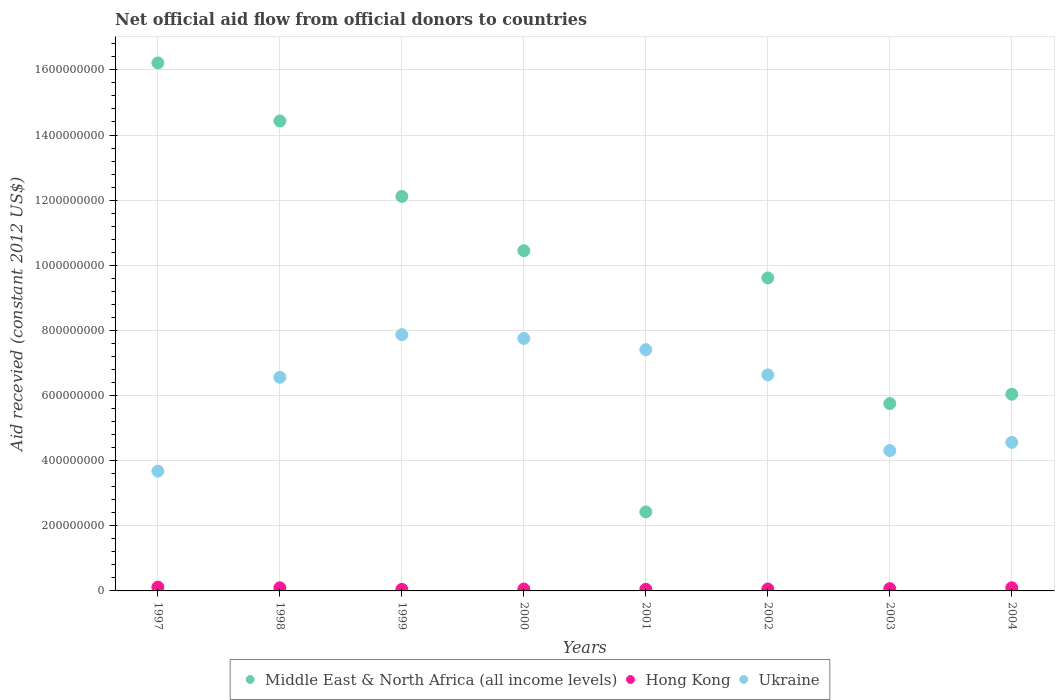How many different coloured dotlines are there?
Give a very brief answer. 3. What is the total aid received in Hong Kong in 1999?
Your answer should be compact. 4.73e+06. Across all years, what is the maximum total aid received in Ukraine?
Ensure brevity in your answer.  7.87e+08. Across all years, what is the minimum total aid received in Hong Kong?
Offer a terse response. 4.73e+06. In which year was the total aid received in Hong Kong maximum?
Offer a very short reply. 1997. What is the total total aid received in Hong Kong in the graph?
Make the answer very short. 5.97e+07. What is the difference between the total aid received in Hong Kong in 1997 and that in 2002?
Offer a very short reply. 5.88e+06. What is the difference between the total aid received in Hong Kong in 1997 and the total aid received in Ukraine in 2000?
Offer a terse response. -7.64e+08. What is the average total aid received in Ukraine per year?
Your answer should be compact. 6.10e+08. In the year 2004, what is the difference between the total aid received in Ukraine and total aid received in Middle East & North Africa (all income levels)?
Your response must be concise. -1.48e+08. What is the ratio of the total aid received in Ukraine in 1998 to that in 2000?
Provide a short and direct response. 0.85. Is the total aid received in Ukraine in 1997 less than that in 2002?
Your answer should be compact. Yes. What is the difference between the highest and the second highest total aid received in Hong Kong?
Offer a terse response. 2.15e+06. What is the difference between the highest and the lowest total aid received in Hong Kong?
Your answer should be compact. 7.07e+06. In how many years, is the total aid received in Ukraine greater than the average total aid received in Ukraine taken over all years?
Your answer should be very brief. 5. Is it the case that in every year, the sum of the total aid received in Hong Kong and total aid received in Ukraine  is greater than the total aid received in Middle East & North Africa (all income levels)?
Your response must be concise. No. Does the total aid received in Middle East & North Africa (all income levels) monotonically increase over the years?
Provide a short and direct response. No. Is the total aid received in Middle East & North Africa (all income levels) strictly less than the total aid received in Ukraine over the years?
Provide a succinct answer. No. How many dotlines are there?
Keep it short and to the point. 3. What is the difference between two consecutive major ticks on the Y-axis?
Your answer should be very brief. 2.00e+08. Does the graph contain any zero values?
Provide a short and direct response. No. Does the graph contain grids?
Your response must be concise. Yes. Where does the legend appear in the graph?
Your answer should be compact. Bottom center. What is the title of the graph?
Offer a terse response. Net official aid flow from official donors to countries. What is the label or title of the X-axis?
Your response must be concise. Years. What is the label or title of the Y-axis?
Provide a succinct answer. Aid recevied (constant 2012 US$). What is the Aid recevied (constant 2012 US$) of Middle East & North Africa (all income levels) in 1997?
Give a very brief answer. 1.62e+09. What is the Aid recevied (constant 2012 US$) of Hong Kong in 1997?
Ensure brevity in your answer.  1.18e+07. What is the Aid recevied (constant 2012 US$) in Ukraine in 1997?
Offer a terse response. 3.68e+08. What is the Aid recevied (constant 2012 US$) in Middle East & North Africa (all income levels) in 1998?
Provide a short and direct response. 1.44e+09. What is the Aid recevied (constant 2012 US$) in Hong Kong in 1998?
Offer a very short reply. 9.64e+06. What is the Aid recevied (constant 2012 US$) in Ukraine in 1998?
Your answer should be compact. 6.56e+08. What is the Aid recevied (constant 2012 US$) in Middle East & North Africa (all income levels) in 1999?
Give a very brief answer. 1.21e+09. What is the Aid recevied (constant 2012 US$) in Hong Kong in 1999?
Provide a succinct answer. 4.73e+06. What is the Aid recevied (constant 2012 US$) in Ukraine in 1999?
Provide a short and direct response. 7.87e+08. What is the Aid recevied (constant 2012 US$) of Middle East & North Africa (all income levels) in 2000?
Your response must be concise. 1.04e+09. What is the Aid recevied (constant 2012 US$) of Hong Kong in 2000?
Give a very brief answer. 5.83e+06. What is the Aid recevied (constant 2012 US$) in Ukraine in 2000?
Your answer should be compact. 7.75e+08. What is the Aid recevied (constant 2012 US$) of Middle East & North Africa (all income levels) in 2001?
Provide a succinct answer. 2.43e+08. What is the Aid recevied (constant 2012 US$) in Hong Kong in 2001?
Your answer should be compact. 5.12e+06. What is the Aid recevied (constant 2012 US$) in Ukraine in 2001?
Your response must be concise. 7.41e+08. What is the Aid recevied (constant 2012 US$) of Middle East & North Africa (all income levels) in 2002?
Offer a terse response. 9.61e+08. What is the Aid recevied (constant 2012 US$) in Hong Kong in 2002?
Keep it short and to the point. 5.92e+06. What is the Aid recevied (constant 2012 US$) in Ukraine in 2002?
Provide a succinct answer. 6.63e+08. What is the Aid recevied (constant 2012 US$) of Middle East & North Africa (all income levels) in 2003?
Offer a terse response. 5.75e+08. What is the Aid recevied (constant 2012 US$) in Hong Kong in 2003?
Give a very brief answer. 6.99e+06. What is the Aid recevied (constant 2012 US$) in Ukraine in 2003?
Ensure brevity in your answer.  4.31e+08. What is the Aid recevied (constant 2012 US$) of Middle East & North Africa (all income levels) in 2004?
Keep it short and to the point. 6.04e+08. What is the Aid recevied (constant 2012 US$) of Hong Kong in 2004?
Ensure brevity in your answer.  9.65e+06. What is the Aid recevied (constant 2012 US$) in Ukraine in 2004?
Your response must be concise. 4.56e+08. Across all years, what is the maximum Aid recevied (constant 2012 US$) of Middle East & North Africa (all income levels)?
Provide a short and direct response. 1.62e+09. Across all years, what is the maximum Aid recevied (constant 2012 US$) in Hong Kong?
Your response must be concise. 1.18e+07. Across all years, what is the maximum Aid recevied (constant 2012 US$) in Ukraine?
Keep it short and to the point. 7.87e+08. Across all years, what is the minimum Aid recevied (constant 2012 US$) in Middle East & North Africa (all income levels)?
Your response must be concise. 2.43e+08. Across all years, what is the minimum Aid recevied (constant 2012 US$) of Hong Kong?
Your answer should be very brief. 4.73e+06. Across all years, what is the minimum Aid recevied (constant 2012 US$) in Ukraine?
Ensure brevity in your answer.  3.68e+08. What is the total Aid recevied (constant 2012 US$) of Middle East & North Africa (all income levels) in the graph?
Your answer should be compact. 7.70e+09. What is the total Aid recevied (constant 2012 US$) of Hong Kong in the graph?
Offer a very short reply. 5.97e+07. What is the total Aid recevied (constant 2012 US$) in Ukraine in the graph?
Your answer should be compact. 4.88e+09. What is the difference between the Aid recevied (constant 2012 US$) of Middle East & North Africa (all income levels) in 1997 and that in 1998?
Make the answer very short. 1.78e+08. What is the difference between the Aid recevied (constant 2012 US$) of Hong Kong in 1997 and that in 1998?
Give a very brief answer. 2.16e+06. What is the difference between the Aid recevied (constant 2012 US$) of Ukraine in 1997 and that in 1998?
Keep it short and to the point. -2.88e+08. What is the difference between the Aid recevied (constant 2012 US$) in Middle East & North Africa (all income levels) in 1997 and that in 1999?
Give a very brief answer. 4.10e+08. What is the difference between the Aid recevied (constant 2012 US$) of Hong Kong in 1997 and that in 1999?
Provide a short and direct response. 7.07e+06. What is the difference between the Aid recevied (constant 2012 US$) in Ukraine in 1997 and that in 1999?
Your response must be concise. -4.19e+08. What is the difference between the Aid recevied (constant 2012 US$) of Middle East & North Africa (all income levels) in 1997 and that in 2000?
Keep it short and to the point. 5.77e+08. What is the difference between the Aid recevied (constant 2012 US$) in Hong Kong in 1997 and that in 2000?
Your answer should be compact. 5.97e+06. What is the difference between the Aid recevied (constant 2012 US$) in Ukraine in 1997 and that in 2000?
Ensure brevity in your answer.  -4.08e+08. What is the difference between the Aid recevied (constant 2012 US$) of Middle East & North Africa (all income levels) in 1997 and that in 2001?
Your response must be concise. 1.38e+09. What is the difference between the Aid recevied (constant 2012 US$) of Hong Kong in 1997 and that in 2001?
Ensure brevity in your answer.  6.68e+06. What is the difference between the Aid recevied (constant 2012 US$) of Ukraine in 1997 and that in 2001?
Provide a short and direct response. -3.73e+08. What is the difference between the Aid recevied (constant 2012 US$) in Middle East & North Africa (all income levels) in 1997 and that in 2002?
Offer a terse response. 6.60e+08. What is the difference between the Aid recevied (constant 2012 US$) of Hong Kong in 1997 and that in 2002?
Provide a short and direct response. 5.88e+06. What is the difference between the Aid recevied (constant 2012 US$) in Ukraine in 1997 and that in 2002?
Keep it short and to the point. -2.96e+08. What is the difference between the Aid recevied (constant 2012 US$) of Middle East & North Africa (all income levels) in 1997 and that in 2003?
Give a very brief answer. 1.05e+09. What is the difference between the Aid recevied (constant 2012 US$) of Hong Kong in 1997 and that in 2003?
Offer a terse response. 4.81e+06. What is the difference between the Aid recevied (constant 2012 US$) of Ukraine in 1997 and that in 2003?
Your response must be concise. -6.32e+07. What is the difference between the Aid recevied (constant 2012 US$) of Middle East & North Africa (all income levels) in 1997 and that in 2004?
Give a very brief answer. 1.02e+09. What is the difference between the Aid recevied (constant 2012 US$) of Hong Kong in 1997 and that in 2004?
Give a very brief answer. 2.15e+06. What is the difference between the Aid recevied (constant 2012 US$) of Ukraine in 1997 and that in 2004?
Offer a terse response. -8.84e+07. What is the difference between the Aid recevied (constant 2012 US$) in Middle East & North Africa (all income levels) in 1998 and that in 1999?
Your answer should be compact. 2.32e+08. What is the difference between the Aid recevied (constant 2012 US$) in Hong Kong in 1998 and that in 1999?
Make the answer very short. 4.91e+06. What is the difference between the Aid recevied (constant 2012 US$) in Ukraine in 1998 and that in 1999?
Your answer should be compact. -1.31e+08. What is the difference between the Aid recevied (constant 2012 US$) in Middle East & North Africa (all income levels) in 1998 and that in 2000?
Your answer should be very brief. 3.98e+08. What is the difference between the Aid recevied (constant 2012 US$) of Hong Kong in 1998 and that in 2000?
Your response must be concise. 3.81e+06. What is the difference between the Aid recevied (constant 2012 US$) of Ukraine in 1998 and that in 2000?
Offer a terse response. -1.19e+08. What is the difference between the Aid recevied (constant 2012 US$) of Middle East & North Africa (all income levels) in 1998 and that in 2001?
Give a very brief answer. 1.20e+09. What is the difference between the Aid recevied (constant 2012 US$) of Hong Kong in 1998 and that in 2001?
Your answer should be compact. 4.52e+06. What is the difference between the Aid recevied (constant 2012 US$) of Ukraine in 1998 and that in 2001?
Give a very brief answer. -8.49e+07. What is the difference between the Aid recevied (constant 2012 US$) in Middle East & North Africa (all income levels) in 1998 and that in 2002?
Your answer should be very brief. 4.82e+08. What is the difference between the Aid recevied (constant 2012 US$) in Hong Kong in 1998 and that in 2002?
Ensure brevity in your answer.  3.72e+06. What is the difference between the Aid recevied (constant 2012 US$) in Ukraine in 1998 and that in 2002?
Give a very brief answer. -7.41e+06. What is the difference between the Aid recevied (constant 2012 US$) in Middle East & North Africa (all income levels) in 1998 and that in 2003?
Your response must be concise. 8.68e+08. What is the difference between the Aid recevied (constant 2012 US$) of Hong Kong in 1998 and that in 2003?
Offer a very short reply. 2.65e+06. What is the difference between the Aid recevied (constant 2012 US$) of Ukraine in 1998 and that in 2003?
Your answer should be compact. 2.25e+08. What is the difference between the Aid recevied (constant 2012 US$) in Middle East & North Africa (all income levels) in 1998 and that in 2004?
Give a very brief answer. 8.39e+08. What is the difference between the Aid recevied (constant 2012 US$) of Hong Kong in 1998 and that in 2004?
Keep it short and to the point. -10000. What is the difference between the Aid recevied (constant 2012 US$) of Ukraine in 1998 and that in 2004?
Your response must be concise. 2.00e+08. What is the difference between the Aid recevied (constant 2012 US$) in Middle East & North Africa (all income levels) in 1999 and that in 2000?
Ensure brevity in your answer.  1.67e+08. What is the difference between the Aid recevied (constant 2012 US$) in Hong Kong in 1999 and that in 2000?
Offer a terse response. -1.10e+06. What is the difference between the Aid recevied (constant 2012 US$) in Ukraine in 1999 and that in 2000?
Offer a terse response. 1.14e+07. What is the difference between the Aid recevied (constant 2012 US$) in Middle East & North Africa (all income levels) in 1999 and that in 2001?
Keep it short and to the point. 9.69e+08. What is the difference between the Aid recevied (constant 2012 US$) of Hong Kong in 1999 and that in 2001?
Ensure brevity in your answer.  -3.90e+05. What is the difference between the Aid recevied (constant 2012 US$) in Ukraine in 1999 and that in 2001?
Offer a very short reply. 4.60e+07. What is the difference between the Aid recevied (constant 2012 US$) of Middle East & North Africa (all income levels) in 1999 and that in 2002?
Make the answer very short. 2.50e+08. What is the difference between the Aid recevied (constant 2012 US$) of Hong Kong in 1999 and that in 2002?
Offer a terse response. -1.19e+06. What is the difference between the Aid recevied (constant 2012 US$) in Ukraine in 1999 and that in 2002?
Provide a succinct answer. 1.23e+08. What is the difference between the Aid recevied (constant 2012 US$) in Middle East & North Africa (all income levels) in 1999 and that in 2003?
Make the answer very short. 6.36e+08. What is the difference between the Aid recevied (constant 2012 US$) of Hong Kong in 1999 and that in 2003?
Your answer should be compact. -2.26e+06. What is the difference between the Aid recevied (constant 2012 US$) in Ukraine in 1999 and that in 2003?
Offer a very short reply. 3.56e+08. What is the difference between the Aid recevied (constant 2012 US$) of Middle East & North Africa (all income levels) in 1999 and that in 2004?
Ensure brevity in your answer.  6.07e+08. What is the difference between the Aid recevied (constant 2012 US$) in Hong Kong in 1999 and that in 2004?
Offer a terse response. -4.92e+06. What is the difference between the Aid recevied (constant 2012 US$) of Ukraine in 1999 and that in 2004?
Offer a very short reply. 3.31e+08. What is the difference between the Aid recevied (constant 2012 US$) of Middle East & North Africa (all income levels) in 2000 and that in 2001?
Offer a terse response. 8.02e+08. What is the difference between the Aid recevied (constant 2012 US$) of Hong Kong in 2000 and that in 2001?
Provide a short and direct response. 7.10e+05. What is the difference between the Aid recevied (constant 2012 US$) of Ukraine in 2000 and that in 2001?
Your response must be concise. 3.46e+07. What is the difference between the Aid recevied (constant 2012 US$) of Middle East & North Africa (all income levels) in 2000 and that in 2002?
Your answer should be compact. 8.36e+07. What is the difference between the Aid recevied (constant 2012 US$) in Hong Kong in 2000 and that in 2002?
Give a very brief answer. -9.00e+04. What is the difference between the Aid recevied (constant 2012 US$) in Ukraine in 2000 and that in 2002?
Your response must be concise. 1.12e+08. What is the difference between the Aid recevied (constant 2012 US$) in Middle East & North Africa (all income levels) in 2000 and that in 2003?
Keep it short and to the point. 4.69e+08. What is the difference between the Aid recevied (constant 2012 US$) of Hong Kong in 2000 and that in 2003?
Provide a succinct answer. -1.16e+06. What is the difference between the Aid recevied (constant 2012 US$) of Ukraine in 2000 and that in 2003?
Give a very brief answer. 3.44e+08. What is the difference between the Aid recevied (constant 2012 US$) of Middle East & North Africa (all income levels) in 2000 and that in 2004?
Provide a succinct answer. 4.41e+08. What is the difference between the Aid recevied (constant 2012 US$) in Hong Kong in 2000 and that in 2004?
Provide a succinct answer. -3.82e+06. What is the difference between the Aid recevied (constant 2012 US$) of Ukraine in 2000 and that in 2004?
Offer a very short reply. 3.19e+08. What is the difference between the Aid recevied (constant 2012 US$) of Middle East & North Africa (all income levels) in 2001 and that in 2002?
Ensure brevity in your answer.  -7.19e+08. What is the difference between the Aid recevied (constant 2012 US$) of Hong Kong in 2001 and that in 2002?
Keep it short and to the point. -8.00e+05. What is the difference between the Aid recevied (constant 2012 US$) of Ukraine in 2001 and that in 2002?
Ensure brevity in your answer.  7.75e+07. What is the difference between the Aid recevied (constant 2012 US$) in Middle East & North Africa (all income levels) in 2001 and that in 2003?
Your answer should be very brief. -3.33e+08. What is the difference between the Aid recevied (constant 2012 US$) in Hong Kong in 2001 and that in 2003?
Your answer should be very brief. -1.87e+06. What is the difference between the Aid recevied (constant 2012 US$) of Ukraine in 2001 and that in 2003?
Keep it short and to the point. 3.10e+08. What is the difference between the Aid recevied (constant 2012 US$) of Middle East & North Africa (all income levels) in 2001 and that in 2004?
Ensure brevity in your answer.  -3.61e+08. What is the difference between the Aid recevied (constant 2012 US$) in Hong Kong in 2001 and that in 2004?
Keep it short and to the point. -4.53e+06. What is the difference between the Aid recevied (constant 2012 US$) of Ukraine in 2001 and that in 2004?
Make the answer very short. 2.85e+08. What is the difference between the Aid recevied (constant 2012 US$) of Middle East & North Africa (all income levels) in 2002 and that in 2003?
Your response must be concise. 3.86e+08. What is the difference between the Aid recevied (constant 2012 US$) in Hong Kong in 2002 and that in 2003?
Provide a succinct answer. -1.07e+06. What is the difference between the Aid recevied (constant 2012 US$) in Ukraine in 2002 and that in 2003?
Offer a very short reply. 2.32e+08. What is the difference between the Aid recevied (constant 2012 US$) of Middle East & North Africa (all income levels) in 2002 and that in 2004?
Your answer should be compact. 3.57e+08. What is the difference between the Aid recevied (constant 2012 US$) in Hong Kong in 2002 and that in 2004?
Keep it short and to the point. -3.73e+06. What is the difference between the Aid recevied (constant 2012 US$) of Ukraine in 2002 and that in 2004?
Your answer should be compact. 2.07e+08. What is the difference between the Aid recevied (constant 2012 US$) of Middle East & North Africa (all income levels) in 2003 and that in 2004?
Your answer should be compact. -2.86e+07. What is the difference between the Aid recevied (constant 2012 US$) of Hong Kong in 2003 and that in 2004?
Your answer should be very brief. -2.66e+06. What is the difference between the Aid recevied (constant 2012 US$) in Ukraine in 2003 and that in 2004?
Offer a very short reply. -2.51e+07. What is the difference between the Aid recevied (constant 2012 US$) in Middle East & North Africa (all income levels) in 1997 and the Aid recevied (constant 2012 US$) in Hong Kong in 1998?
Your response must be concise. 1.61e+09. What is the difference between the Aid recevied (constant 2012 US$) of Middle East & North Africa (all income levels) in 1997 and the Aid recevied (constant 2012 US$) of Ukraine in 1998?
Your answer should be compact. 9.65e+08. What is the difference between the Aid recevied (constant 2012 US$) in Hong Kong in 1997 and the Aid recevied (constant 2012 US$) in Ukraine in 1998?
Provide a short and direct response. -6.44e+08. What is the difference between the Aid recevied (constant 2012 US$) in Middle East & North Africa (all income levels) in 1997 and the Aid recevied (constant 2012 US$) in Hong Kong in 1999?
Keep it short and to the point. 1.62e+09. What is the difference between the Aid recevied (constant 2012 US$) of Middle East & North Africa (all income levels) in 1997 and the Aid recevied (constant 2012 US$) of Ukraine in 1999?
Provide a succinct answer. 8.35e+08. What is the difference between the Aid recevied (constant 2012 US$) in Hong Kong in 1997 and the Aid recevied (constant 2012 US$) in Ukraine in 1999?
Give a very brief answer. -7.75e+08. What is the difference between the Aid recevied (constant 2012 US$) of Middle East & North Africa (all income levels) in 1997 and the Aid recevied (constant 2012 US$) of Hong Kong in 2000?
Provide a short and direct response. 1.62e+09. What is the difference between the Aid recevied (constant 2012 US$) of Middle East & North Africa (all income levels) in 1997 and the Aid recevied (constant 2012 US$) of Ukraine in 2000?
Your response must be concise. 8.46e+08. What is the difference between the Aid recevied (constant 2012 US$) in Hong Kong in 1997 and the Aid recevied (constant 2012 US$) in Ukraine in 2000?
Your answer should be compact. -7.64e+08. What is the difference between the Aid recevied (constant 2012 US$) of Middle East & North Africa (all income levels) in 1997 and the Aid recevied (constant 2012 US$) of Hong Kong in 2001?
Give a very brief answer. 1.62e+09. What is the difference between the Aid recevied (constant 2012 US$) in Middle East & North Africa (all income levels) in 1997 and the Aid recevied (constant 2012 US$) in Ukraine in 2001?
Provide a short and direct response. 8.81e+08. What is the difference between the Aid recevied (constant 2012 US$) of Hong Kong in 1997 and the Aid recevied (constant 2012 US$) of Ukraine in 2001?
Your answer should be compact. -7.29e+08. What is the difference between the Aid recevied (constant 2012 US$) of Middle East & North Africa (all income levels) in 1997 and the Aid recevied (constant 2012 US$) of Hong Kong in 2002?
Provide a short and direct response. 1.62e+09. What is the difference between the Aid recevied (constant 2012 US$) in Middle East & North Africa (all income levels) in 1997 and the Aid recevied (constant 2012 US$) in Ukraine in 2002?
Your answer should be compact. 9.58e+08. What is the difference between the Aid recevied (constant 2012 US$) in Hong Kong in 1997 and the Aid recevied (constant 2012 US$) in Ukraine in 2002?
Make the answer very short. -6.52e+08. What is the difference between the Aid recevied (constant 2012 US$) of Middle East & North Africa (all income levels) in 1997 and the Aid recevied (constant 2012 US$) of Hong Kong in 2003?
Ensure brevity in your answer.  1.61e+09. What is the difference between the Aid recevied (constant 2012 US$) of Middle East & North Africa (all income levels) in 1997 and the Aid recevied (constant 2012 US$) of Ukraine in 2003?
Your answer should be very brief. 1.19e+09. What is the difference between the Aid recevied (constant 2012 US$) in Hong Kong in 1997 and the Aid recevied (constant 2012 US$) in Ukraine in 2003?
Offer a terse response. -4.19e+08. What is the difference between the Aid recevied (constant 2012 US$) of Middle East & North Africa (all income levels) in 1997 and the Aid recevied (constant 2012 US$) of Hong Kong in 2004?
Offer a very short reply. 1.61e+09. What is the difference between the Aid recevied (constant 2012 US$) in Middle East & North Africa (all income levels) in 1997 and the Aid recevied (constant 2012 US$) in Ukraine in 2004?
Your response must be concise. 1.17e+09. What is the difference between the Aid recevied (constant 2012 US$) of Hong Kong in 1997 and the Aid recevied (constant 2012 US$) of Ukraine in 2004?
Ensure brevity in your answer.  -4.44e+08. What is the difference between the Aid recevied (constant 2012 US$) in Middle East & North Africa (all income levels) in 1998 and the Aid recevied (constant 2012 US$) in Hong Kong in 1999?
Keep it short and to the point. 1.44e+09. What is the difference between the Aid recevied (constant 2012 US$) in Middle East & North Africa (all income levels) in 1998 and the Aid recevied (constant 2012 US$) in Ukraine in 1999?
Give a very brief answer. 6.56e+08. What is the difference between the Aid recevied (constant 2012 US$) in Hong Kong in 1998 and the Aid recevied (constant 2012 US$) in Ukraine in 1999?
Give a very brief answer. -7.77e+08. What is the difference between the Aid recevied (constant 2012 US$) of Middle East & North Africa (all income levels) in 1998 and the Aid recevied (constant 2012 US$) of Hong Kong in 2000?
Offer a very short reply. 1.44e+09. What is the difference between the Aid recevied (constant 2012 US$) in Middle East & North Africa (all income levels) in 1998 and the Aid recevied (constant 2012 US$) in Ukraine in 2000?
Provide a short and direct response. 6.68e+08. What is the difference between the Aid recevied (constant 2012 US$) in Hong Kong in 1998 and the Aid recevied (constant 2012 US$) in Ukraine in 2000?
Keep it short and to the point. -7.66e+08. What is the difference between the Aid recevied (constant 2012 US$) in Middle East & North Africa (all income levels) in 1998 and the Aid recevied (constant 2012 US$) in Hong Kong in 2001?
Give a very brief answer. 1.44e+09. What is the difference between the Aid recevied (constant 2012 US$) of Middle East & North Africa (all income levels) in 1998 and the Aid recevied (constant 2012 US$) of Ukraine in 2001?
Keep it short and to the point. 7.02e+08. What is the difference between the Aid recevied (constant 2012 US$) in Hong Kong in 1998 and the Aid recevied (constant 2012 US$) in Ukraine in 2001?
Offer a terse response. -7.31e+08. What is the difference between the Aid recevied (constant 2012 US$) in Middle East & North Africa (all income levels) in 1998 and the Aid recevied (constant 2012 US$) in Hong Kong in 2002?
Provide a succinct answer. 1.44e+09. What is the difference between the Aid recevied (constant 2012 US$) in Middle East & North Africa (all income levels) in 1998 and the Aid recevied (constant 2012 US$) in Ukraine in 2002?
Provide a succinct answer. 7.80e+08. What is the difference between the Aid recevied (constant 2012 US$) in Hong Kong in 1998 and the Aid recevied (constant 2012 US$) in Ukraine in 2002?
Give a very brief answer. -6.54e+08. What is the difference between the Aid recevied (constant 2012 US$) of Middle East & North Africa (all income levels) in 1998 and the Aid recevied (constant 2012 US$) of Hong Kong in 2003?
Your answer should be compact. 1.44e+09. What is the difference between the Aid recevied (constant 2012 US$) of Middle East & North Africa (all income levels) in 1998 and the Aid recevied (constant 2012 US$) of Ukraine in 2003?
Keep it short and to the point. 1.01e+09. What is the difference between the Aid recevied (constant 2012 US$) of Hong Kong in 1998 and the Aid recevied (constant 2012 US$) of Ukraine in 2003?
Offer a very short reply. -4.21e+08. What is the difference between the Aid recevied (constant 2012 US$) of Middle East & North Africa (all income levels) in 1998 and the Aid recevied (constant 2012 US$) of Hong Kong in 2004?
Give a very brief answer. 1.43e+09. What is the difference between the Aid recevied (constant 2012 US$) of Middle East & North Africa (all income levels) in 1998 and the Aid recevied (constant 2012 US$) of Ukraine in 2004?
Your answer should be very brief. 9.87e+08. What is the difference between the Aid recevied (constant 2012 US$) in Hong Kong in 1998 and the Aid recevied (constant 2012 US$) in Ukraine in 2004?
Give a very brief answer. -4.47e+08. What is the difference between the Aid recevied (constant 2012 US$) in Middle East & North Africa (all income levels) in 1999 and the Aid recevied (constant 2012 US$) in Hong Kong in 2000?
Give a very brief answer. 1.21e+09. What is the difference between the Aid recevied (constant 2012 US$) in Middle East & North Africa (all income levels) in 1999 and the Aid recevied (constant 2012 US$) in Ukraine in 2000?
Your answer should be very brief. 4.36e+08. What is the difference between the Aid recevied (constant 2012 US$) of Hong Kong in 1999 and the Aid recevied (constant 2012 US$) of Ukraine in 2000?
Offer a very short reply. -7.71e+08. What is the difference between the Aid recevied (constant 2012 US$) in Middle East & North Africa (all income levels) in 1999 and the Aid recevied (constant 2012 US$) in Hong Kong in 2001?
Provide a short and direct response. 1.21e+09. What is the difference between the Aid recevied (constant 2012 US$) of Middle East & North Africa (all income levels) in 1999 and the Aid recevied (constant 2012 US$) of Ukraine in 2001?
Provide a succinct answer. 4.70e+08. What is the difference between the Aid recevied (constant 2012 US$) of Hong Kong in 1999 and the Aid recevied (constant 2012 US$) of Ukraine in 2001?
Provide a short and direct response. -7.36e+08. What is the difference between the Aid recevied (constant 2012 US$) of Middle East & North Africa (all income levels) in 1999 and the Aid recevied (constant 2012 US$) of Hong Kong in 2002?
Your response must be concise. 1.21e+09. What is the difference between the Aid recevied (constant 2012 US$) of Middle East & North Africa (all income levels) in 1999 and the Aid recevied (constant 2012 US$) of Ukraine in 2002?
Your response must be concise. 5.48e+08. What is the difference between the Aid recevied (constant 2012 US$) of Hong Kong in 1999 and the Aid recevied (constant 2012 US$) of Ukraine in 2002?
Provide a short and direct response. -6.59e+08. What is the difference between the Aid recevied (constant 2012 US$) of Middle East & North Africa (all income levels) in 1999 and the Aid recevied (constant 2012 US$) of Hong Kong in 2003?
Offer a terse response. 1.20e+09. What is the difference between the Aid recevied (constant 2012 US$) of Middle East & North Africa (all income levels) in 1999 and the Aid recevied (constant 2012 US$) of Ukraine in 2003?
Offer a terse response. 7.80e+08. What is the difference between the Aid recevied (constant 2012 US$) of Hong Kong in 1999 and the Aid recevied (constant 2012 US$) of Ukraine in 2003?
Provide a short and direct response. -4.26e+08. What is the difference between the Aid recevied (constant 2012 US$) in Middle East & North Africa (all income levels) in 1999 and the Aid recevied (constant 2012 US$) in Hong Kong in 2004?
Give a very brief answer. 1.20e+09. What is the difference between the Aid recevied (constant 2012 US$) of Middle East & North Africa (all income levels) in 1999 and the Aid recevied (constant 2012 US$) of Ukraine in 2004?
Offer a very short reply. 7.55e+08. What is the difference between the Aid recevied (constant 2012 US$) of Hong Kong in 1999 and the Aid recevied (constant 2012 US$) of Ukraine in 2004?
Offer a very short reply. -4.51e+08. What is the difference between the Aid recevied (constant 2012 US$) of Middle East & North Africa (all income levels) in 2000 and the Aid recevied (constant 2012 US$) of Hong Kong in 2001?
Offer a very short reply. 1.04e+09. What is the difference between the Aid recevied (constant 2012 US$) of Middle East & North Africa (all income levels) in 2000 and the Aid recevied (constant 2012 US$) of Ukraine in 2001?
Provide a short and direct response. 3.04e+08. What is the difference between the Aid recevied (constant 2012 US$) of Hong Kong in 2000 and the Aid recevied (constant 2012 US$) of Ukraine in 2001?
Keep it short and to the point. -7.35e+08. What is the difference between the Aid recevied (constant 2012 US$) in Middle East & North Africa (all income levels) in 2000 and the Aid recevied (constant 2012 US$) in Hong Kong in 2002?
Offer a very short reply. 1.04e+09. What is the difference between the Aid recevied (constant 2012 US$) of Middle East & North Africa (all income levels) in 2000 and the Aid recevied (constant 2012 US$) of Ukraine in 2002?
Keep it short and to the point. 3.81e+08. What is the difference between the Aid recevied (constant 2012 US$) of Hong Kong in 2000 and the Aid recevied (constant 2012 US$) of Ukraine in 2002?
Provide a succinct answer. -6.58e+08. What is the difference between the Aid recevied (constant 2012 US$) of Middle East & North Africa (all income levels) in 2000 and the Aid recevied (constant 2012 US$) of Hong Kong in 2003?
Provide a succinct answer. 1.04e+09. What is the difference between the Aid recevied (constant 2012 US$) in Middle East & North Africa (all income levels) in 2000 and the Aid recevied (constant 2012 US$) in Ukraine in 2003?
Ensure brevity in your answer.  6.14e+08. What is the difference between the Aid recevied (constant 2012 US$) in Hong Kong in 2000 and the Aid recevied (constant 2012 US$) in Ukraine in 2003?
Offer a terse response. -4.25e+08. What is the difference between the Aid recevied (constant 2012 US$) in Middle East & North Africa (all income levels) in 2000 and the Aid recevied (constant 2012 US$) in Hong Kong in 2004?
Offer a very short reply. 1.04e+09. What is the difference between the Aid recevied (constant 2012 US$) of Middle East & North Africa (all income levels) in 2000 and the Aid recevied (constant 2012 US$) of Ukraine in 2004?
Offer a terse response. 5.89e+08. What is the difference between the Aid recevied (constant 2012 US$) in Hong Kong in 2000 and the Aid recevied (constant 2012 US$) in Ukraine in 2004?
Offer a terse response. -4.50e+08. What is the difference between the Aid recevied (constant 2012 US$) in Middle East & North Africa (all income levels) in 2001 and the Aid recevied (constant 2012 US$) in Hong Kong in 2002?
Your answer should be compact. 2.37e+08. What is the difference between the Aid recevied (constant 2012 US$) in Middle East & North Africa (all income levels) in 2001 and the Aid recevied (constant 2012 US$) in Ukraine in 2002?
Your response must be concise. -4.21e+08. What is the difference between the Aid recevied (constant 2012 US$) in Hong Kong in 2001 and the Aid recevied (constant 2012 US$) in Ukraine in 2002?
Your answer should be very brief. -6.58e+08. What is the difference between the Aid recevied (constant 2012 US$) of Middle East & North Africa (all income levels) in 2001 and the Aid recevied (constant 2012 US$) of Hong Kong in 2003?
Keep it short and to the point. 2.36e+08. What is the difference between the Aid recevied (constant 2012 US$) in Middle East & North Africa (all income levels) in 2001 and the Aid recevied (constant 2012 US$) in Ukraine in 2003?
Provide a succinct answer. -1.89e+08. What is the difference between the Aid recevied (constant 2012 US$) of Hong Kong in 2001 and the Aid recevied (constant 2012 US$) of Ukraine in 2003?
Your response must be concise. -4.26e+08. What is the difference between the Aid recevied (constant 2012 US$) in Middle East & North Africa (all income levels) in 2001 and the Aid recevied (constant 2012 US$) in Hong Kong in 2004?
Offer a very short reply. 2.33e+08. What is the difference between the Aid recevied (constant 2012 US$) of Middle East & North Africa (all income levels) in 2001 and the Aid recevied (constant 2012 US$) of Ukraine in 2004?
Make the answer very short. -2.14e+08. What is the difference between the Aid recevied (constant 2012 US$) of Hong Kong in 2001 and the Aid recevied (constant 2012 US$) of Ukraine in 2004?
Keep it short and to the point. -4.51e+08. What is the difference between the Aid recevied (constant 2012 US$) in Middle East & North Africa (all income levels) in 2002 and the Aid recevied (constant 2012 US$) in Hong Kong in 2003?
Keep it short and to the point. 9.54e+08. What is the difference between the Aid recevied (constant 2012 US$) in Middle East & North Africa (all income levels) in 2002 and the Aid recevied (constant 2012 US$) in Ukraine in 2003?
Provide a short and direct response. 5.30e+08. What is the difference between the Aid recevied (constant 2012 US$) in Hong Kong in 2002 and the Aid recevied (constant 2012 US$) in Ukraine in 2003?
Give a very brief answer. -4.25e+08. What is the difference between the Aid recevied (constant 2012 US$) in Middle East & North Africa (all income levels) in 2002 and the Aid recevied (constant 2012 US$) in Hong Kong in 2004?
Your response must be concise. 9.52e+08. What is the difference between the Aid recevied (constant 2012 US$) in Middle East & North Africa (all income levels) in 2002 and the Aid recevied (constant 2012 US$) in Ukraine in 2004?
Your response must be concise. 5.05e+08. What is the difference between the Aid recevied (constant 2012 US$) in Hong Kong in 2002 and the Aid recevied (constant 2012 US$) in Ukraine in 2004?
Give a very brief answer. -4.50e+08. What is the difference between the Aid recevied (constant 2012 US$) in Middle East & North Africa (all income levels) in 2003 and the Aid recevied (constant 2012 US$) in Hong Kong in 2004?
Your answer should be compact. 5.66e+08. What is the difference between the Aid recevied (constant 2012 US$) in Middle East & North Africa (all income levels) in 2003 and the Aid recevied (constant 2012 US$) in Ukraine in 2004?
Your answer should be compact. 1.19e+08. What is the difference between the Aid recevied (constant 2012 US$) in Hong Kong in 2003 and the Aid recevied (constant 2012 US$) in Ukraine in 2004?
Keep it short and to the point. -4.49e+08. What is the average Aid recevied (constant 2012 US$) in Middle East & North Africa (all income levels) per year?
Your answer should be compact. 9.63e+08. What is the average Aid recevied (constant 2012 US$) in Hong Kong per year?
Your answer should be very brief. 7.46e+06. What is the average Aid recevied (constant 2012 US$) of Ukraine per year?
Your answer should be very brief. 6.10e+08. In the year 1997, what is the difference between the Aid recevied (constant 2012 US$) in Middle East & North Africa (all income levels) and Aid recevied (constant 2012 US$) in Hong Kong?
Offer a terse response. 1.61e+09. In the year 1997, what is the difference between the Aid recevied (constant 2012 US$) in Middle East & North Africa (all income levels) and Aid recevied (constant 2012 US$) in Ukraine?
Offer a very short reply. 1.25e+09. In the year 1997, what is the difference between the Aid recevied (constant 2012 US$) of Hong Kong and Aid recevied (constant 2012 US$) of Ukraine?
Ensure brevity in your answer.  -3.56e+08. In the year 1998, what is the difference between the Aid recevied (constant 2012 US$) of Middle East & North Africa (all income levels) and Aid recevied (constant 2012 US$) of Hong Kong?
Provide a short and direct response. 1.43e+09. In the year 1998, what is the difference between the Aid recevied (constant 2012 US$) of Middle East & North Africa (all income levels) and Aid recevied (constant 2012 US$) of Ukraine?
Provide a short and direct response. 7.87e+08. In the year 1998, what is the difference between the Aid recevied (constant 2012 US$) in Hong Kong and Aid recevied (constant 2012 US$) in Ukraine?
Your answer should be compact. -6.46e+08. In the year 1999, what is the difference between the Aid recevied (constant 2012 US$) in Middle East & North Africa (all income levels) and Aid recevied (constant 2012 US$) in Hong Kong?
Provide a short and direct response. 1.21e+09. In the year 1999, what is the difference between the Aid recevied (constant 2012 US$) in Middle East & North Africa (all income levels) and Aid recevied (constant 2012 US$) in Ukraine?
Your response must be concise. 4.24e+08. In the year 1999, what is the difference between the Aid recevied (constant 2012 US$) of Hong Kong and Aid recevied (constant 2012 US$) of Ukraine?
Your answer should be compact. -7.82e+08. In the year 2000, what is the difference between the Aid recevied (constant 2012 US$) in Middle East & North Africa (all income levels) and Aid recevied (constant 2012 US$) in Hong Kong?
Provide a succinct answer. 1.04e+09. In the year 2000, what is the difference between the Aid recevied (constant 2012 US$) in Middle East & North Africa (all income levels) and Aid recevied (constant 2012 US$) in Ukraine?
Your answer should be compact. 2.69e+08. In the year 2000, what is the difference between the Aid recevied (constant 2012 US$) in Hong Kong and Aid recevied (constant 2012 US$) in Ukraine?
Ensure brevity in your answer.  -7.70e+08. In the year 2001, what is the difference between the Aid recevied (constant 2012 US$) in Middle East & North Africa (all income levels) and Aid recevied (constant 2012 US$) in Hong Kong?
Give a very brief answer. 2.37e+08. In the year 2001, what is the difference between the Aid recevied (constant 2012 US$) of Middle East & North Africa (all income levels) and Aid recevied (constant 2012 US$) of Ukraine?
Make the answer very short. -4.98e+08. In the year 2001, what is the difference between the Aid recevied (constant 2012 US$) of Hong Kong and Aid recevied (constant 2012 US$) of Ukraine?
Your answer should be very brief. -7.36e+08. In the year 2002, what is the difference between the Aid recevied (constant 2012 US$) in Middle East & North Africa (all income levels) and Aid recevied (constant 2012 US$) in Hong Kong?
Keep it short and to the point. 9.55e+08. In the year 2002, what is the difference between the Aid recevied (constant 2012 US$) in Middle East & North Africa (all income levels) and Aid recevied (constant 2012 US$) in Ukraine?
Offer a very short reply. 2.98e+08. In the year 2002, what is the difference between the Aid recevied (constant 2012 US$) in Hong Kong and Aid recevied (constant 2012 US$) in Ukraine?
Provide a succinct answer. -6.57e+08. In the year 2003, what is the difference between the Aid recevied (constant 2012 US$) of Middle East & North Africa (all income levels) and Aid recevied (constant 2012 US$) of Hong Kong?
Your answer should be very brief. 5.68e+08. In the year 2003, what is the difference between the Aid recevied (constant 2012 US$) of Middle East & North Africa (all income levels) and Aid recevied (constant 2012 US$) of Ukraine?
Make the answer very short. 1.44e+08. In the year 2003, what is the difference between the Aid recevied (constant 2012 US$) of Hong Kong and Aid recevied (constant 2012 US$) of Ukraine?
Provide a short and direct response. -4.24e+08. In the year 2004, what is the difference between the Aid recevied (constant 2012 US$) in Middle East & North Africa (all income levels) and Aid recevied (constant 2012 US$) in Hong Kong?
Your response must be concise. 5.94e+08. In the year 2004, what is the difference between the Aid recevied (constant 2012 US$) in Middle East & North Africa (all income levels) and Aid recevied (constant 2012 US$) in Ukraine?
Offer a very short reply. 1.48e+08. In the year 2004, what is the difference between the Aid recevied (constant 2012 US$) in Hong Kong and Aid recevied (constant 2012 US$) in Ukraine?
Keep it short and to the point. -4.47e+08. What is the ratio of the Aid recevied (constant 2012 US$) in Middle East & North Africa (all income levels) in 1997 to that in 1998?
Provide a succinct answer. 1.12. What is the ratio of the Aid recevied (constant 2012 US$) of Hong Kong in 1997 to that in 1998?
Ensure brevity in your answer.  1.22. What is the ratio of the Aid recevied (constant 2012 US$) of Ukraine in 1997 to that in 1998?
Your answer should be compact. 0.56. What is the ratio of the Aid recevied (constant 2012 US$) in Middle East & North Africa (all income levels) in 1997 to that in 1999?
Your answer should be very brief. 1.34. What is the ratio of the Aid recevied (constant 2012 US$) in Hong Kong in 1997 to that in 1999?
Your answer should be compact. 2.49. What is the ratio of the Aid recevied (constant 2012 US$) of Ukraine in 1997 to that in 1999?
Provide a succinct answer. 0.47. What is the ratio of the Aid recevied (constant 2012 US$) in Middle East & North Africa (all income levels) in 1997 to that in 2000?
Keep it short and to the point. 1.55. What is the ratio of the Aid recevied (constant 2012 US$) in Hong Kong in 1997 to that in 2000?
Your response must be concise. 2.02. What is the ratio of the Aid recevied (constant 2012 US$) in Ukraine in 1997 to that in 2000?
Your answer should be compact. 0.47. What is the ratio of the Aid recevied (constant 2012 US$) of Middle East & North Africa (all income levels) in 1997 to that in 2001?
Keep it short and to the point. 6.69. What is the ratio of the Aid recevied (constant 2012 US$) in Hong Kong in 1997 to that in 2001?
Ensure brevity in your answer.  2.3. What is the ratio of the Aid recevied (constant 2012 US$) in Ukraine in 1997 to that in 2001?
Your answer should be compact. 0.5. What is the ratio of the Aid recevied (constant 2012 US$) of Middle East & North Africa (all income levels) in 1997 to that in 2002?
Give a very brief answer. 1.69. What is the ratio of the Aid recevied (constant 2012 US$) in Hong Kong in 1997 to that in 2002?
Give a very brief answer. 1.99. What is the ratio of the Aid recevied (constant 2012 US$) in Ukraine in 1997 to that in 2002?
Give a very brief answer. 0.55. What is the ratio of the Aid recevied (constant 2012 US$) in Middle East & North Africa (all income levels) in 1997 to that in 2003?
Give a very brief answer. 2.82. What is the ratio of the Aid recevied (constant 2012 US$) in Hong Kong in 1997 to that in 2003?
Your answer should be compact. 1.69. What is the ratio of the Aid recevied (constant 2012 US$) of Ukraine in 1997 to that in 2003?
Your response must be concise. 0.85. What is the ratio of the Aid recevied (constant 2012 US$) of Middle East & North Africa (all income levels) in 1997 to that in 2004?
Make the answer very short. 2.68. What is the ratio of the Aid recevied (constant 2012 US$) of Hong Kong in 1997 to that in 2004?
Provide a succinct answer. 1.22. What is the ratio of the Aid recevied (constant 2012 US$) in Ukraine in 1997 to that in 2004?
Your answer should be compact. 0.81. What is the ratio of the Aid recevied (constant 2012 US$) in Middle East & North Africa (all income levels) in 1998 to that in 1999?
Your response must be concise. 1.19. What is the ratio of the Aid recevied (constant 2012 US$) of Hong Kong in 1998 to that in 1999?
Provide a succinct answer. 2.04. What is the ratio of the Aid recevied (constant 2012 US$) in Ukraine in 1998 to that in 1999?
Your answer should be very brief. 0.83. What is the ratio of the Aid recevied (constant 2012 US$) of Middle East & North Africa (all income levels) in 1998 to that in 2000?
Make the answer very short. 1.38. What is the ratio of the Aid recevied (constant 2012 US$) in Hong Kong in 1998 to that in 2000?
Offer a terse response. 1.65. What is the ratio of the Aid recevied (constant 2012 US$) in Ukraine in 1998 to that in 2000?
Ensure brevity in your answer.  0.85. What is the ratio of the Aid recevied (constant 2012 US$) in Middle East & North Africa (all income levels) in 1998 to that in 2001?
Ensure brevity in your answer.  5.95. What is the ratio of the Aid recevied (constant 2012 US$) of Hong Kong in 1998 to that in 2001?
Offer a terse response. 1.88. What is the ratio of the Aid recevied (constant 2012 US$) in Ukraine in 1998 to that in 2001?
Keep it short and to the point. 0.89. What is the ratio of the Aid recevied (constant 2012 US$) of Middle East & North Africa (all income levels) in 1998 to that in 2002?
Your response must be concise. 1.5. What is the ratio of the Aid recevied (constant 2012 US$) in Hong Kong in 1998 to that in 2002?
Offer a terse response. 1.63. What is the ratio of the Aid recevied (constant 2012 US$) of Ukraine in 1998 to that in 2002?
Make the answer very short. 0.99. What is the ratio of the Aid recevied (constant 2012 US$) in Middle East & North Africa (all income levels) in 1998 to that in 2003?
Ensure brevity in your answer.  2.51. What is the ratio of the Aid recevied (constant 2012 US$) in Hong Kong in 1998 to that in 2003?
Give a very brief answer. 1.38. What is the ratio of the Aid recevied (constant 2012 US$) of Ukraine in 1998 to that in 2003?
Make the answer very short. 1.52. What is the ratio of the Aid recevied (constant 2012 US$) in Middle East & North Africa (all income levels) in 1998 to that in 2004?
Provide a short and direct response. 2.39. What is the ratio of the Aid recevied (constant 2012 US$) in Hong Kong in 1998 to that in 2004?
Offer a very short reply. 1. What is the ratio of the Aid recevied (constant 2012 US$) of Ukraine in 1998 to that in 2004?
Provide a succinct answer. 1.44. What is the ratio of the Aid recevied (constant 2012 US$) of Middle East & North Africa (all income levels) in 1999 to that in 2000?
Your answer should be compact. 1.16. What is the ratio of the Aid recevied (constant 2012 US$) in Hong Kong in 1999 to that in 2000?
Make the answer very short. 0.81. What is the ratio of the Aid recevied (constant 2012 US$) of Ukraine in 1999 to that in 2000?
Offer a terse response. 1.01. What is the ratio of the Aid recevied (constant 2012 US$) in Middle East & North Africa (all income levels) in 1999 to that in 2001?
Keep it short and to the point. 4.99. What is the ratio of the Aid recevied (constant 2012 US$) in Hong Kong in 1999 to that in 2001?
Your response must be concise. 0.92. What is the ratio of the Aid recevied (constant 2012 US$) in Ukraine in 1999 to that in 2001?
Provide a succinct answer. 1.06. What is the ratio of the Aid recevied (constant 2012 US$) of Middle East & North Africa (all income levels) in 1999 to that in 2002?
Give a very brief answer. 1.26. What is the ratio of the Aid recevied (constant 2012 US$) in Hong Kong in 1999 to that in 2002?
Offer a terse response. 0.8. What is the ratio of the Aid recevied (constant 2012 US$) of Ukraine in 1999 to that in 2002?
Give a very brief answer. 1.19. What is the ratio of the Aid recevied (constant 2012 US$) of Middle East & North Africa (all income levels) in 1999 to that in 2003?
Offer a terse response. 2.11. What is the ratio of the Aid recevied (constant 2012 US$) of Hong Kong in 1999 to that in 2003?
Offer a very short reply. 0.68. What is the ratio of the Aid recevied (constant 2012 US$) of Ukraine in 1999 to that in 2003?
Ensure brevity in your answer.  1.83. What is the ratio of the Aid recevied (constant 2012 US$) in Middle East & North Africa (all income levels) in 1999 to that in 2004?
Your response must be concise. 2.01. What is the ratio of the Aid recevied (constant 2012 US$) in Hong Kong in 1999 to that in 2004?
Offer a very short reply. 0.49. What is the ratio of the Aid recevied (constant 2012 US$) of Ukraine in 1999 to that in 2004?
Provide a short and direct response. 1.72. What is the ratio of the Aid recevied (constant 2012 US$) of Middle East & North Africa (all income levels) in 2000 to that in 2001?
Your answer should be compact. 4.31. What is the ratio of the Aid recevied (constant 2012 US$) of Hong Kong in 2000 to that in 2001?
Your response must be concise. 1.14. What is the ratio of the Aid recevied (constant 2012 US$) of Ukraine in 2000 to that in 2001?
Ensure brevity in your answer.  1.05. What is the ratio of the Aid recevied (constant 2012 US$) in Middle East & North Africa (all income levels) in 2000 to that in 2002?
Provide a short and direct response. 1.09. What is the ratio of the Aid recevied (constant 2012 US$) of Hong Kong in 2000 to that in 2002?
Give a very brief answer. 0.98. What is the ratio of the Aid recevied (constant 2012 US$) of Ukraine in 2000 to that in 2002?
Make the answer very short. 1.17. What is the ratio of the Aid recevied (constant 2012 US$) in Middle East & North Africa (all income levels) in 2000 to that in 2003?
Keep it short and to the point. 1.82. What is the ratio of the Aid recevied (constant 2012 US$) of Hong Kong in 2000 to that in 2003?
Provide a succinct answer. 0.83. What is the ratio of the Aid recevied (constant 2012 US$) in Ukraine in 2000 to that in 2003?
Your answer should be very brief. 1.8. What is the ratio of the Aid recevied (constant 2012 US$) in Middle East & North Africa (all income levels) in 2000 to that in 2004?
Offer a very short reply. 1.73. What is the ratio of the Aid recevied (constant 2012 US$) of Hong Kong in 2000 to that in 2004?
Your answer should be very brief. 0.6. What is the ratio of the Aid recevied (constant 2012 US$) of Ukraine in 2000 to that in 2004?
Keep it short and to the point. 1.7. What is the ratio of the Aid recevied (constant 2012 US$) of Middle East & North Africa (all income levels) in 2001 to that in 2002?
Offer a terse response. 0.25. What is the ratio of the Aid recevied (constant 2012 US$) of Hong Kong in 2001 to that in 2002?
Provide a short and direct response. 0.86. What is the ratio of the Aid recevied (constant 2012 US$) in Ukraine in 2001 to that in 2002?
Keep it short and to the point. 1.12. What is the ratio of the Aid recevied (constant 2012 US$) in Middle East & North Africa (all income levels) in 2001 to that in 2003?
Your answer should be compact. 0.42. What is the ratio of the Aid recevied (constant 2012 US$) in Hong Kong in 2001 to that in 2003?
Offer a very short reply. 0.73. What is the ratio of the Aid recevied (constant 2012 US$) of Ukraine in 2001 to that in 2003?
Your response must be concise. 1.72. What is the ratio of the Aid recevied (constant 2012 US$) of Middle East & North Africa (all income levels) in 2001 to that in 2004?
Your answer should be compact. 0.4. What is the ratio of the Aid recevied (constant 2012 US$) of Hong Kong in 2001 to that in 2004?
Keep it short and to the point. 0.53. What is the ratio of the Aid recevied (constant 2012 US$) of Ukraine in 2001 to that in 2004?
Your answer should be compact. 1.62. What is the ratio of the Aid recevied (constant 2012 US$) of Middle East & North Africa (all income levels) in 2002 to that in 2003?
Offer a very short reply. 1.67. What is the ratio of the Aid recevied (constant 2012 US$) in Hong Kong in 2002 to that in 2003?
Make the answer very short. 0.85. What is the ratio of the Aid recevied (constant 2012 US$) in Ukraine in 2002 to that in 2003?
Offer a terse response. 1.54. What is the ratio of the Aid recevied (constant 2012 US$) of Middle East & North Africa (all income levels) in 2002 to that in 2004?
Keep it short and to the point. 1.59. What is the ratio of the Aid recevied (constant 2012 US$) in Hong Kong in 2002 to that in 2004?
Ensure brevity in your answer.  0.61. What is the ratio of the Aid recevied (constant 2012 US$) in Ukraine in 2002 to that in 2004?
Your answer should be very brief. 1.45. What is the ratio of the Aid recevied (constant 2012 US$) of Middle East & North Africa (all income levels) in 2003 to that in 2004?
Make the answer very short. 0.95. What is the ratio of the Aid recevied (constant 2012 US$) in Hong Kong in 2003 to that in 2004?
Offer a very short reply. 0.72. What is the ratio of the Aid recevied (constant 2012 US$) of Ukraine in 2003 to that in 2004?
Offer a terse response. 0.94. What is the difference between the highest and the second highest Aid recevied (constant 2012 US$) in Middle East & North Africa (all income levels)?
Your answer should be compact. 1.78e+08. What is the difference between the highest and the second highest Aid recevied (constant 2012 US$) in Hong Kong?
Ensure brevity in your answer.  2.15e+06. What is the difference between the highest and the second highest Aid recevied (constant 2012 US$) of Ukraine?
Ensure brevity in your answer.  1.14e+07. What is the difference between the highest and the lowest Aid recevied (constant 2012 US$) of Middle East & North Africa (all income levels)?
Keep it short and to the point. 1.38e+09. What is the difference between the highest and the lowest Aid recevied (constant 2012 US$) in Hong Kong?
Your answer should be very brief. 7.07e+06. What is the difference between the highest and the lowest Aid recevied (constant 2012 US$) in Ukraine?
Ensure brevity in your answer.  4.19e+08. 